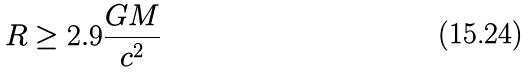<formula> <loc_0><loc_0><loc_500><loc_500>R \geq 2 . 9 \frac { G M } { c ^ { 2 } }</formula> 